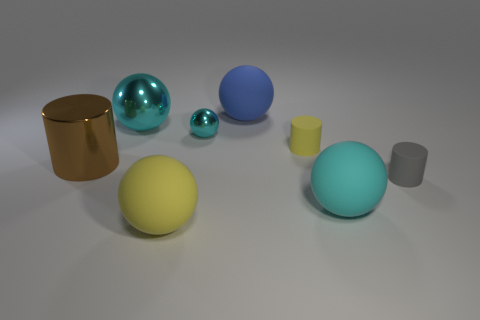Subtract all yellow cubes. How many cyan spheres are left? 3 Subtract all blue balls. How many balls are left? 4 Subtract all yellow matte spheres. How many spheres are left? 4 Subtract 1 balls. How many balls are left? 4 Add 2 small brown cylinders. How many objects exist? 10 Subtract all brown spheres. Subtract all gray cylinders. How many spheres are left? 5 Subtract all cylinders. How many objects are left? 5 Subtract all small gray objects. Subtract all tiny cyan spheres. How many objects are left? 6 Add 4 big brown shiny cylinders. How many big brown shiny cylinders are left? 5 Add 2 balls. How many balls exist? 7 